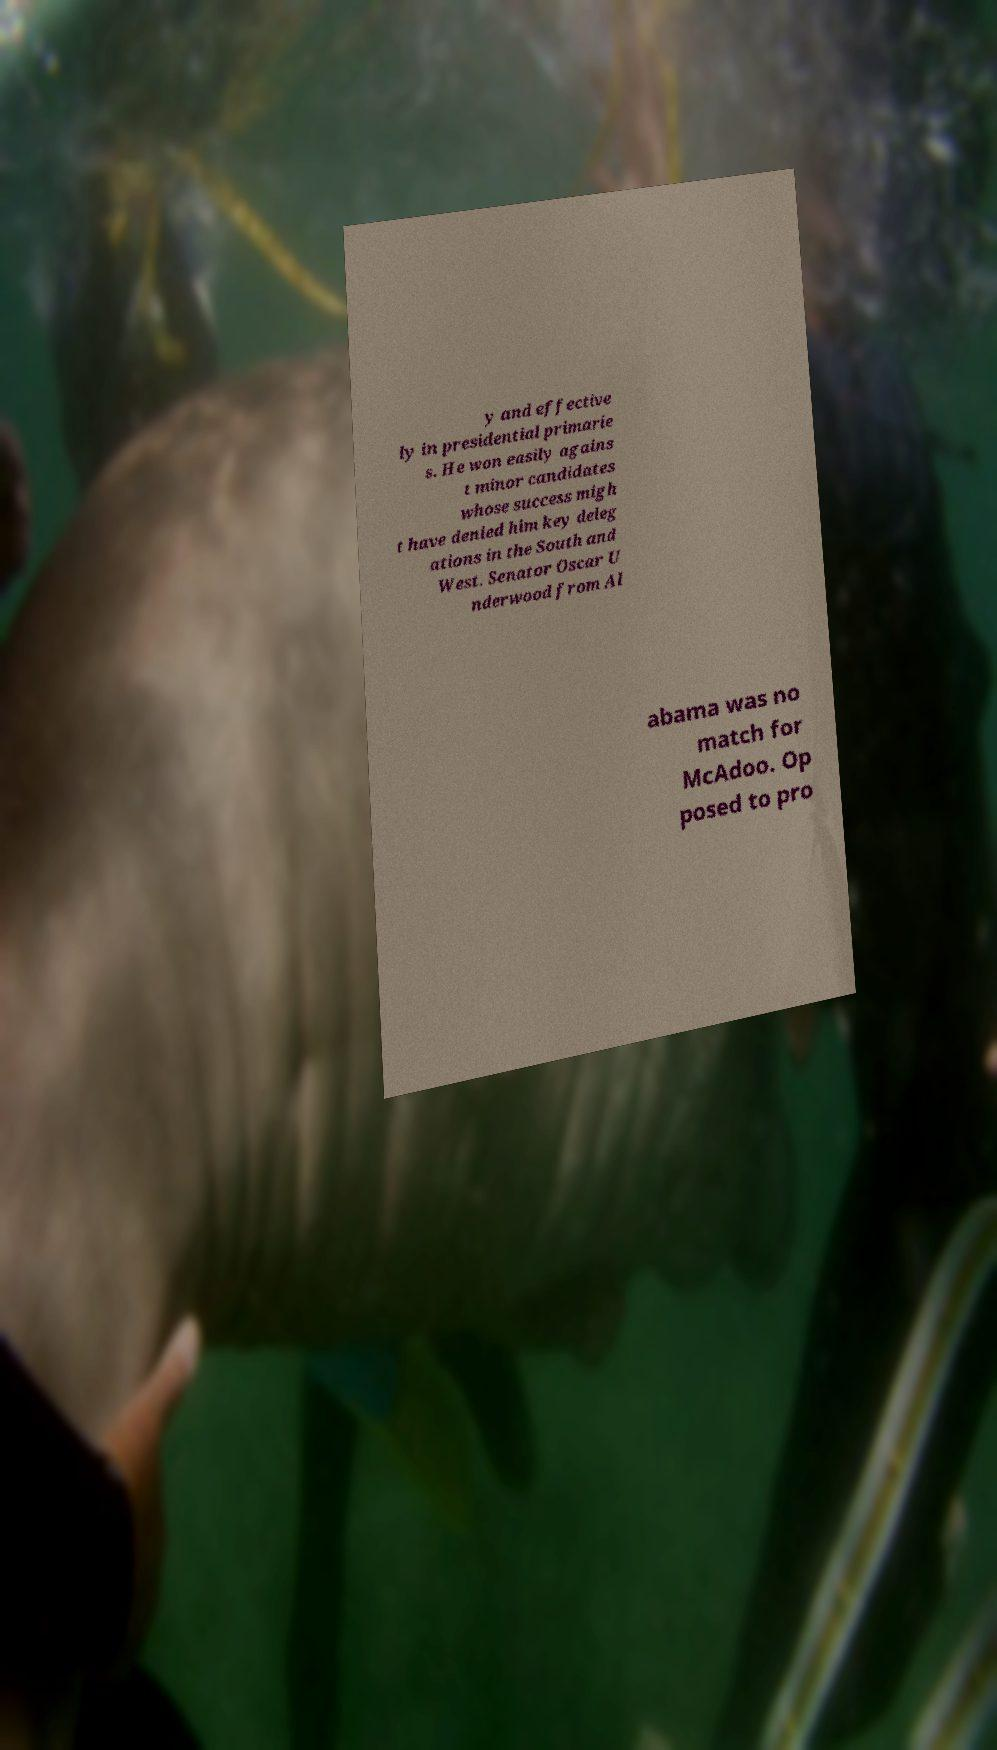Please read and relay the text visible in this image. What does it say? y and effective ly in presidential primarie s. He won easily agains t minor candidates whose success migh t have denied him key deleg ations in the South and West. Senator Oscar U nderwood from Al abama was no match for McAdoo. Op posed to pro 